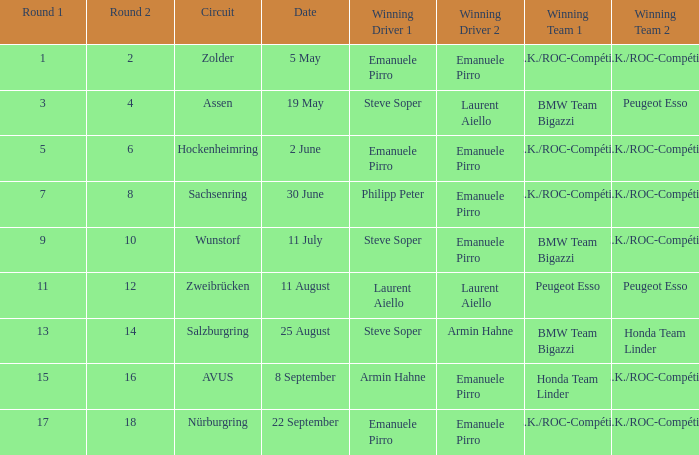Parse the table in full. {'header': ['Round 1', 'Round 2', 'Circuit', 'Date', 'Winning Driver 1', 'Winning Driver 2', 'Winning Team 1', 'Winning Team 2'], 'rows': [['1', '2', 'Zolder', '5 May', 'Emanuele Pirro', 'Emanuele Pirro', 'A.Z.K./ROC-Compétition', 'A.Z.K./ROC-Compétition'], ['3', '4', 'Assen', '19 May', 'Steve Soper', 'Laurent Aiello', 'BMW Team Bigazzi', 'Peugeot Esso'], ['5', '6', 'Hockenheimring', '2 June', 'Emanuele Pirro', 'Emanuele Pirro', 'A.Z.K./ROC-Compétition', 'A.Z.K./ROC-Compétition'], ['7', '8', 'Sachsenring', '30 June', 'Philipp Peter', 'Emanuele Pirro', 'A.Z.K./ROC-Compétition', 'A.Z.K./ROC-Compétition'], ['9', '10', 'Wunstorf', '11 July', 'Steve Soper', 'Emanuele Pirro', 'BMW Team Bigazzi', 'A.Z.K./ROC-Compétition'], ['11', '12', 'Zweibrücken', '11 August', 'Laurent Aiello', 'Laurent Aiello', 'Peugeot Esso', 'Peugeot Esso'], ['13', '14', 'Salzburgring', '25 August', 'Steve Soper', 'Armin Hahne', 'BMW Team Bigazzi', 'Honda Team Linder'], ['15', '16', 'AVUS', '8 September', 'Armin Hahne', 'Emanuele Pirro', 'Honda Team Linder', 'A.Z.K./ROC-Compétition'], ['17', '18', 'Nürburgring', '22 September', 'Emanuele Pirro', 'Emanuele Pirro', 'A.Z.K./ROC-Compétition', 'A.Z.K./ROC-Compétition']]} When did the zolder circuit event occur, where a.z.k./roc-compétition emerged as the winning team? 5 May. 